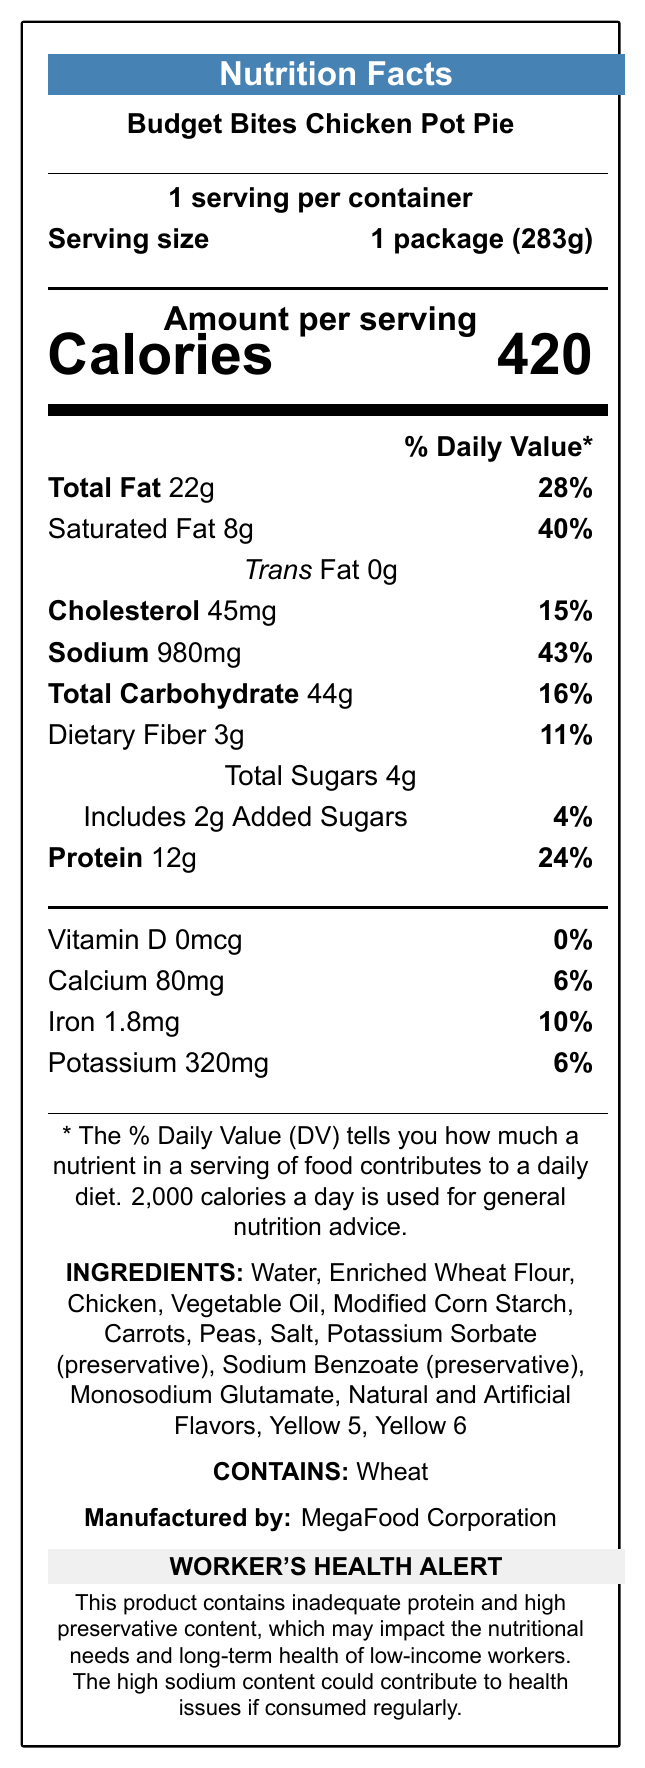what is the serving size of the Budget Bites Chicken Pot Pie? The serving size is clearly mentioned as "1 package (283g)" in the document.
Answer: 1 package (283g) How many calories are in a serving of Budget Bites Chicken Pot Pie? The document states that there are 420 calories per serving.
Answer: 420 calories List the preservatives found in this product. The preservatives listed in the ingredients are Potassium Sorbate and Sodium Benzoate.
Answer: Potassium Sorbate, Sodium Benzoate What is the protein content per serving? The protein content per serving is 12 grams, as shown on the label.
Answer: 12g How much sodium is in one serving? One serving contains 980mg of sodium.
Answer: 980mg What percent of the daily value of saturated fat does this product contain? The document states that the product contains 40% of the daily value for saturated fat.
Answer: 40% How many total sugars are in a serving? The total sugars in a serving are 4 grams.
Answer: 4g Which of the following is an artificial color used in this product? A. Blue 1 B. Yellow 5 C. Red 40 D. Green 3 The artificial colors listed in the ingredients are Yellow 5 and Yellow 6. Yellow 5 is the correct option.
Answer: B. Yellow 5 What health concerns might arise from consuming this product regularly? A. High cholesterol B. Low protein intake C. High sodium intake D. Both B and C The document notes concerns about inadequate protein and high sodium content, both of which could lead to health issues.
Answer: D. Both B and C Is there any vitamin D in this product? The label states that there is 0mcg of Vitamin D, which is 0% of the daily value.
Answer: No Does this product contain any allergens? The document states that the product contains wheat.
Answer: Yes What are the total fat and its percentage daily value? The total fat content is 22g, and the percentage daily value is 28%.
Answer: 22g, 28% Summarize the main nutritional and health concerns presented in this document. The document outlines that the frozen TV dinner is nutritionally inadequate in terms of protein, has a high sodium level, and contains multiple preservatives and artificial additives, which may impact long-term health.
Answer: The Budget Bites Chicken Pot Pie contains inadequate protein, high sodium, and numerous preservatives, posing potential nutritional and health risks to low-income workers who may rely on such meals. How is the product distributed? The document indicates that the product is distributed through discount stores and dollar shops.
Answer: Sold in discount stores and dollar shops frequently accessed by low-income workers What is the daily value percentage of dietary fiber in a serving? The label shows that the dietary fiber content is 11% of the daily value.
Answer: 11% 